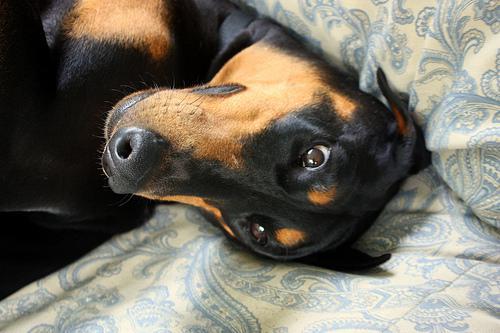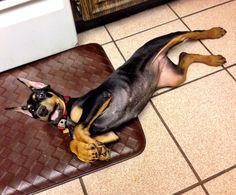The first image is the image on the left, the second image is the image on the right. For the images displayed, is the sentence "A person sitting on upholstered furniture on the left of one image is touching the belly of a dog lying on its back with its front paws bent forward and hind legs extended." factually correct? Answer yes or no. No. The first image is the image on the left, the second image is the image on the right. Given the left and right images, does the statement "The dog in one of the images is getting its belly rubbed." hold true? Answer yes or no. No. 